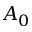<formula> <loc_0><loc_0><loc_500><loc_500>A _ { 0 }</formula> 